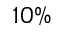<formula> <loc_0><loc_0><loc_500><loc_500>1 0 \%</formula> 